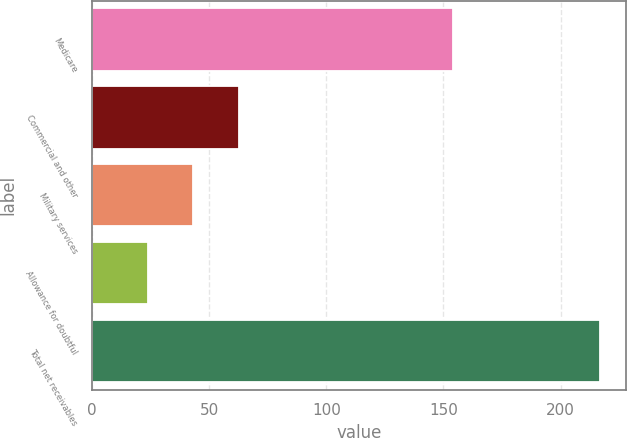Convert chart to OTSL. <chart><loc_0><loc_0><loc_500><loc_500><bar_chart><fcel>Medicare<fcel>Commercial and other<fcel>Military services<fcel>Allowance for doubtful<fcel>Total net receivables<nl><fcel>154<fcel>62.6<fcel>43.3<fcel>24<fcel>217<nl></chart> 